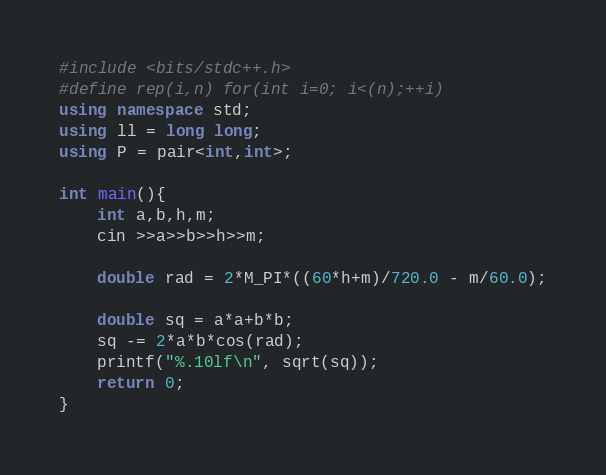<code> <loc_0><loc_0><loc_500><loc_500><_C++_>#include <bits/stdc++.h>
#define rep(i,n) for(int i=0; i<(n);++i)
using namespace std;
using ll = long long;
using P = pair<int,int>;

int main(){
    int a,b,h,m;
    cin >>a>>b>>h>>m;
    
    double rad = 2*M_PI*((60*h+m)/720.0 - m/60.0);
    
    double sq = a*a+b*b;
    sq -= 2*a*b*cos(rad);
    printf("%.10lf\n", sqrt(sq));
    return 0;
}</code> 